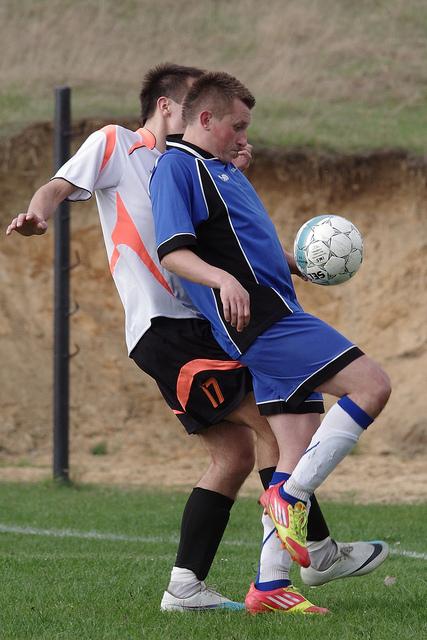Why are the men wearing helmets?
Short answer required. They aren't. Are both players on the same team?
Short answer required. No. What is the name of the game these men are playing?
Short answer required. Soccer. What type of ball is that?
Write a very short answer. Soccer. What sport is being played?
Quick response, please. Soccer. 